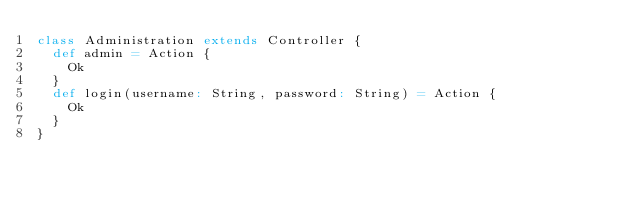<code> <loc_0><loc_0><loc_500><loc_500><_Scala_>class Administration extends Controller {
	def admin = Action {
		Ok
	}
	def login(username: String, password: String) = Action {
		Ok
	}
}
</code> 